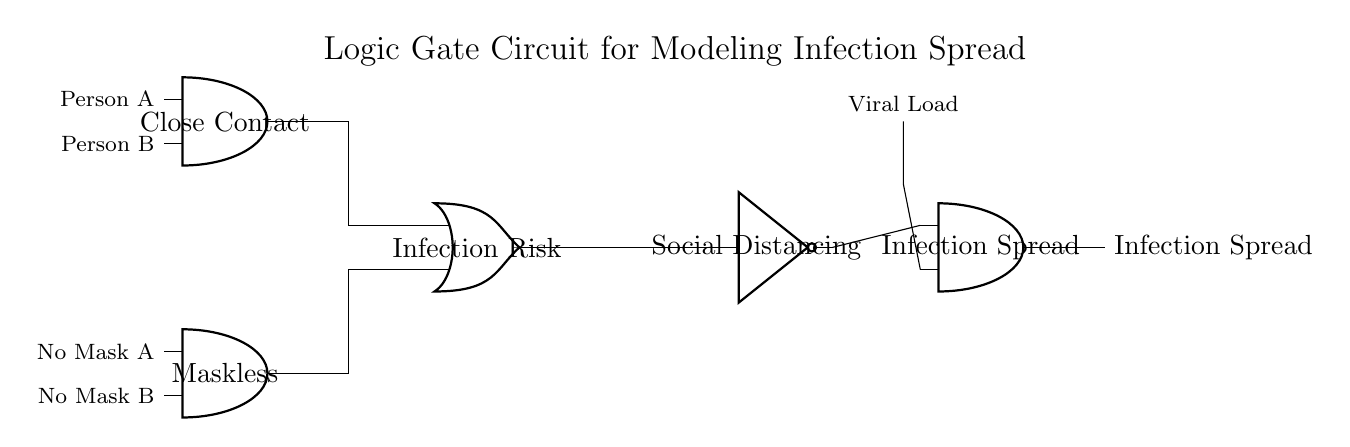What are the two input types for the AND gate on the left? The two input types for the AND gate are "Close Contact" and "Maskless", which represent conditions necessary for possible infection spread.
Answer: Close contact, maskless What is the output of the OR gate? The output of the OR gate is "Infection Risk", which combines the inputs from the two AND gates to indicate whether there is a risk of infection based on contact and masking conditions.
Answer: Infection Risk What role does the NOT gate play in this circuit? The NOT gate, labeled as "Social Distancing", inversely represents the impact of social distancing on the infection spread, meaning that if social distancing is implemented (output is false), it contributes towards less spread.
Answer: Decreases spread How many AND gates are there in the circuit? The circuit contains three AND gates, indicated at various points: one for close contact, one for the conjunction of infection risk from prior gates, and the last for final output of infection spread.
Answer: Three Which logical operation represents the condition for Infection Spread? The Infection Spread is determined by the output of the last AND gate, which takes inputs from the Infection Risk and the output of the NOT gate regarding social distancing.
Answer: AND operation What do the inputs labeled "No Mask A" and "No Mask B" signify in the circuit? The inputs "No Mask A" and "No Mask B" indicate the masking condition for Persons A and B, crucial in assessing the infection risk as they are part of the input to the OR gate combining contact conditions.
Answer: Mask status What does the arrow leading to the "Infection Spread" output indicate? The arrow signifies the resulting flow of information indicating that if conditions for both infection risk and lack of effective social distancing are met, then there is a resultant infection spread.
Answer: Infection spread result 